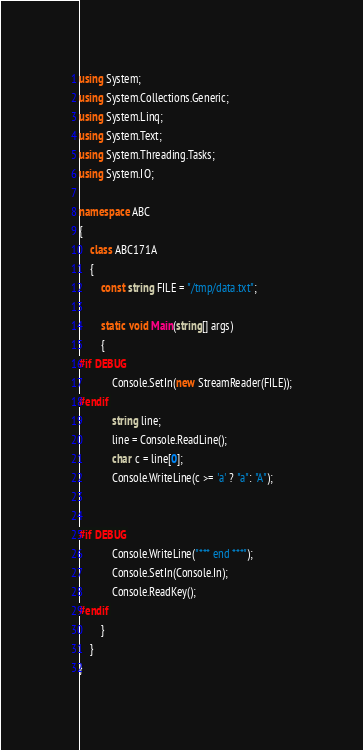<code> <loc_0><loc_0><loc_500><loc_500><_C#_>using System;
using System.Collections.Generic;
using System.Linq;
using System.Text;
using System.Threading.Tasks;
using System.IO;

namespace ABC
{
    class ABC171A
    {
        const string FILE = "/tmp/data.txt";

        static void Main(string[] args)
        {
#if DEBUG
            Console.SetIn(new StreamReader(FILE));
#endif
            string line;
            line = Console.ReadLine();
            char c = line[0];
            Console.WriteLine(c >= 'a' ? "a": "A");


#if DEBUG
            Console.WriteLine("*** end ***");
            Console.SetIn(Console.In);
            Console.ReadKey();
#endif
        }
    }
}
</code> 